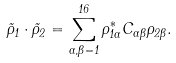Convert formula to latex. <formula><loc_0><loc_0><loc_500><loc_500>\vec { \rho } _ { 1 } \cdot \vec { \rho } _ { 2 } = \sum _ { \alpha , \beta = 1 } ^ { 1 6 } \rho _ { 1 \alpha } ^ { * } C _ { \alpha \beta } \rho _ { 2 \beta } .</formula> 